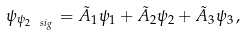Convert formula to latex. <formula><loc_0><loc_0><loc_500><loc_500>\psi _ { \psi _ { 2 \ s i _ { g } } } = \tilde { A } _ { 1 } \psi _ { 1 } + \tilde { A } _ { 2 } \psi _ { 2 } + \tilde { A } _ { 3 } \psi _ { 3 } \, ,</formula> 